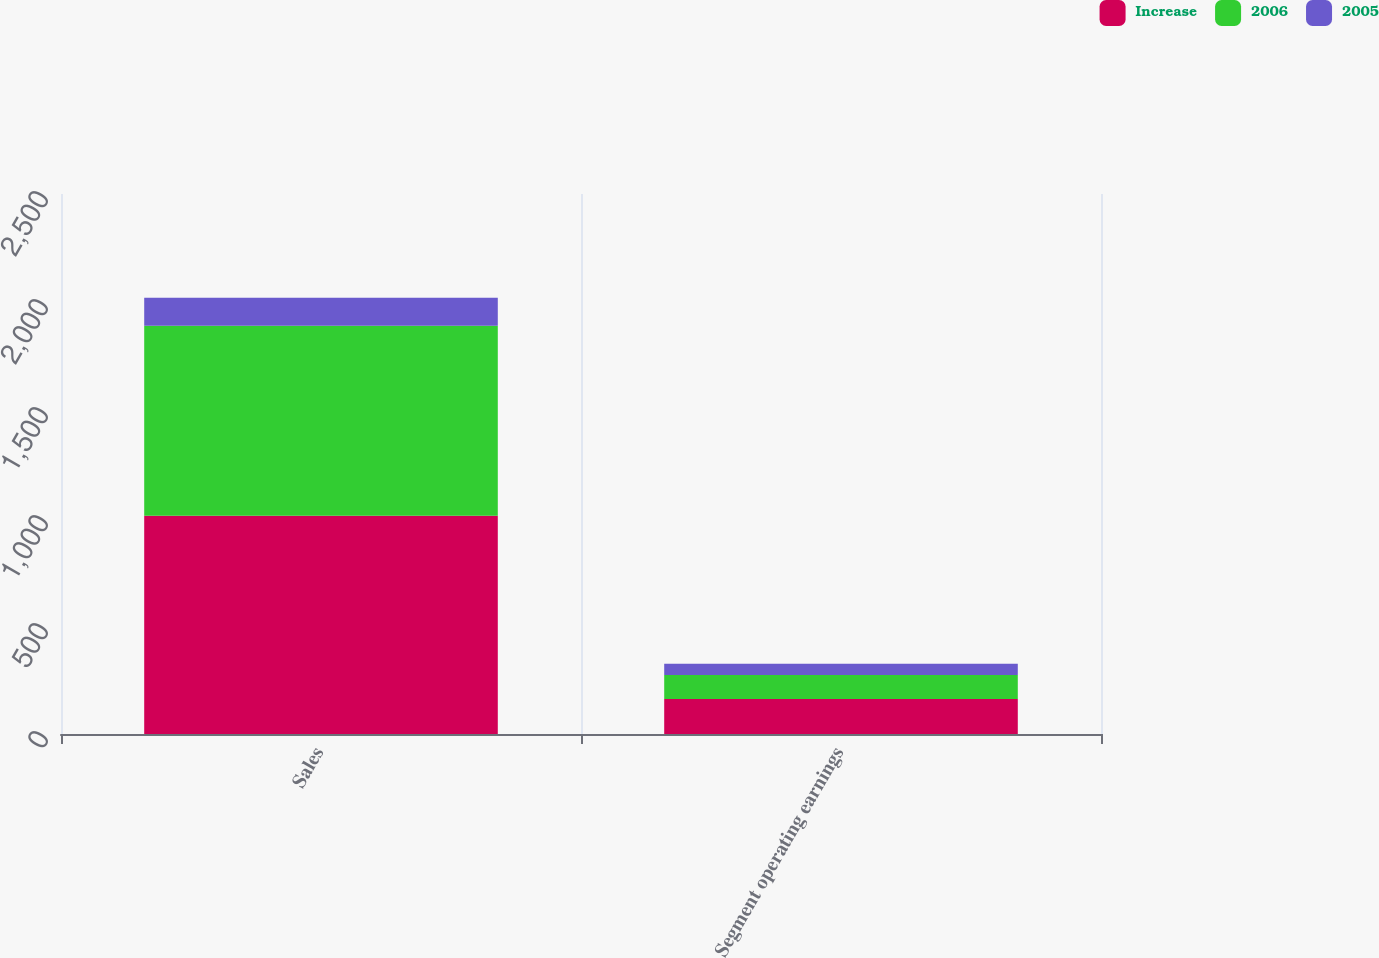Convert chart. <chart><loc_0><loc_0><loc_500><loc_500><stacked_bar_chart><ecel><fcel>Sales<fcel>Segment operating earnings<nl><fcel>Increase<fcel>1010.1<fcel>162.6<nl><fcel>2006<fcel>879.6<fcel>110.3<nl><fcel>2005<fcel>130.5<fcel>52.3<nl></chart> 